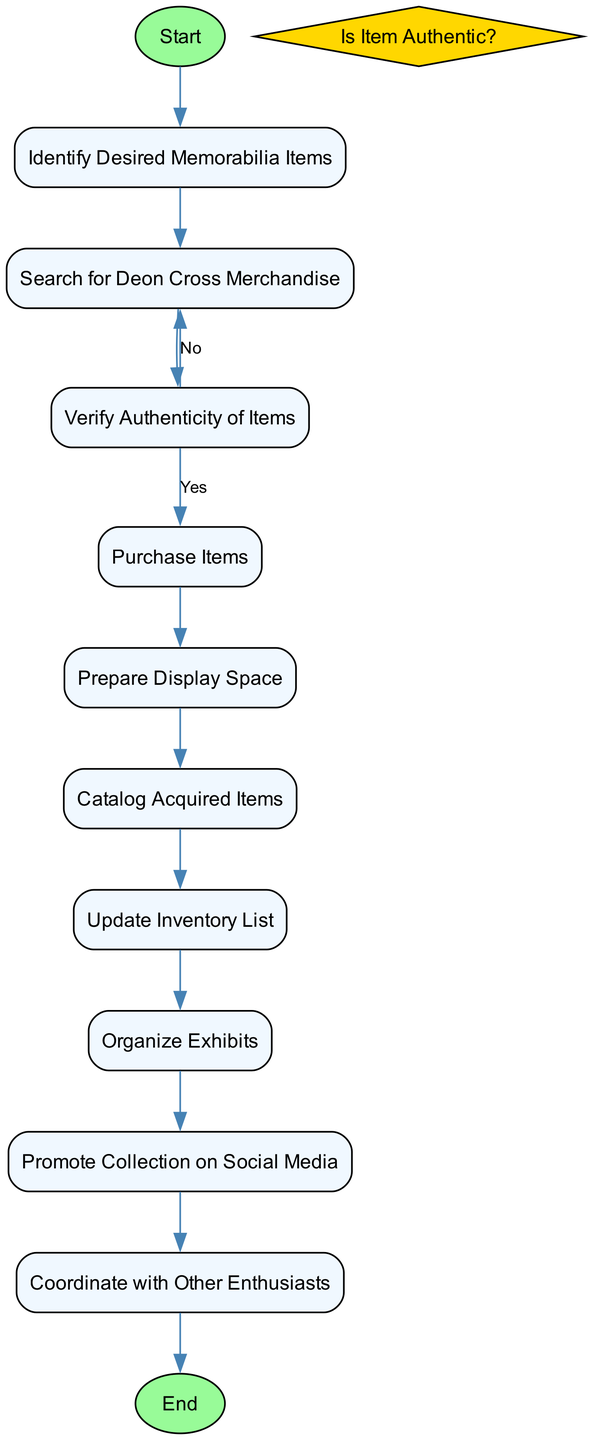What is the starting activity in the diagram? The diagram indicates that the starting activity is labeled as 'Identify Desired Memorabilia Items'. This is the very first node that initiates the flow of activities in the diagram.
Answer: Identify Desired Memorabilia Items How many activities are there in total? By counting the distinct activities listed within the diagram, we find that there are ten unique activities that are part of the process.
Answer: 10 What is the last activity to be completed? The final activity in the diagram concludes with 'Coordinate with Other Enthusiasts'. This is the endpoint where all the previous actions lead to collaboration with other fans.
Answer: Coordinate with Other Enthusiasts What happens if the item is found to be not authentic? If the item is deemed not authentic, the next step involves searching for Deon Cross merchandise again, which redirects back to the search process in the diagram.
Answer: Search for Deon Cross Merchandise What activity follows after purchasing items? Once items are purchased, the subsequent activity as per the flow diagram is 'Prepare Display Space'. This indicates the need to ready an area for showcasing the memorabilia.
Answer: Prepare Display Space How does 'Promote Collection on Social Media' connect to the previous steps? This activity is reached only after completing the organization of exhibits. It demonstrates a flow from organizing exhibits directly to promoting the collection publicly, highlighting its marketing aspect.
Answer: Organize Exhibits What decision needs to be made during the process? The decision represented in the diagram is whether the item is authentic or not, which influences subsequent actions taken in the collection process.
Answer: Is Item Authentic? Which activity directly leads to updating the inventory list? The activity 'Catalog Acquired Items' is the step that directly leads to 'Update Inventory List', showcasing the chaining of tasks necessary for maintaining accurate records.
Answer: Update Inventory List How many edges connect the decision node to other activities? Examining the diagram, the decision node 'Is Item Authentic?' is connected by two edges: one leading to 'Purchase Items' if the response is 'Yes', and another leading back to 'Search for Deon Cross Merchandise' if 'No'.
Answer: 2 